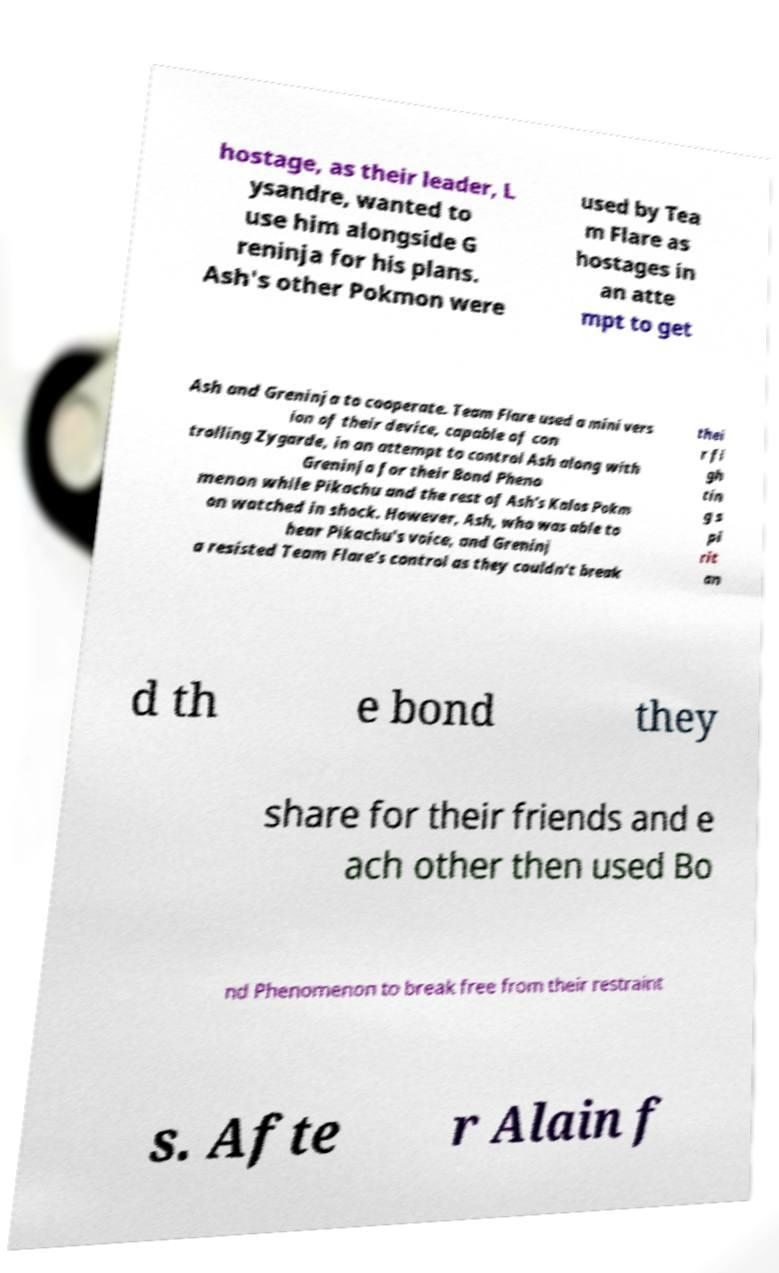Can you accurately transcribe the text from the provided image for me? hostage, as their leader, L ysandre, wanted to use him alongside G reninja for his plans. Ash's other Pokmon were used by Tea m Flare as hostages in an atte mpt to get Ash and Greninja to cooperate. Team Flare used a mini vers ion of their device, capable of con trolling Zygarde, in an attempt to control Ash along with Greninja for their Bond Pheno menon while Pikachu and the rest of Ash's Kalos Pokm on watched in shock. However, Ash, who was able to hear Pikachu's voice, and Greninj a resisted Team Flare's control as they couldn't break thei r fi gh tin g s pi rit an d th e bond they share for their friends and e ach other then used Bo nd Phenomenon to break free from their restraint s. Afte r Alain f 